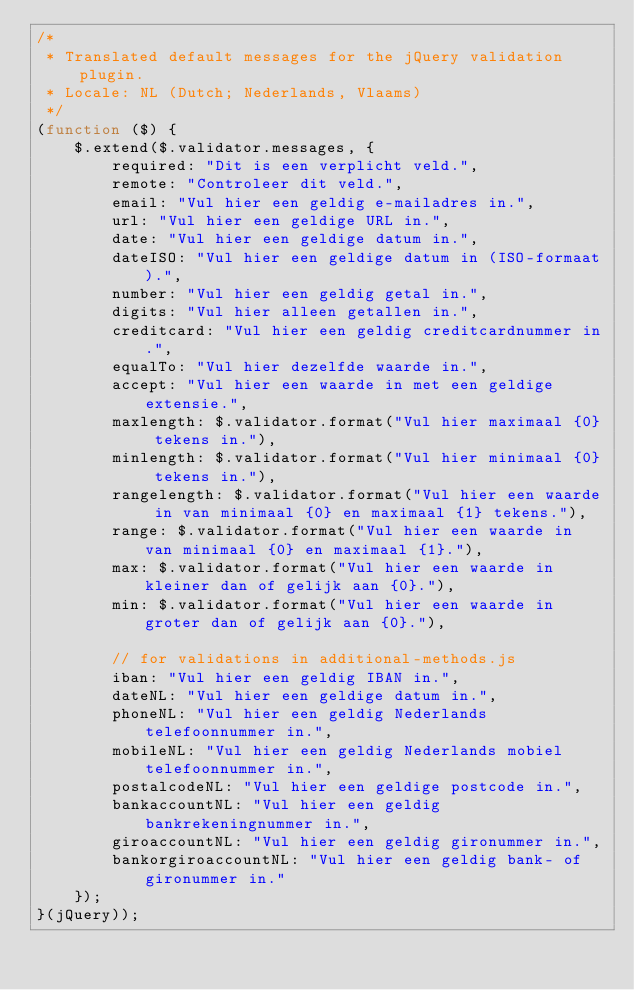<code> <loc_0><loc_0><loc_500><loc_500><_JavaScript_>/*
 * Translated default messages for the jQuery validation plugin.
 * Locale: NL (Dutch; Nederlands, Vlaams)
 */
(function ($) {
    $.extend($.validator.messages, {
        required: "Dit is een verplicht veld.",
        remote: "Controleer dit veld.",
        email: "Vul hier een geldig e-mailadres in.",
        url: "Vul hier een geldige URL in.",
        date: "Vul hier een geldige datum in.",
        dateISO: "Vul hier een geldige datum in (ISO-formaat).",
        number: "Vul hier een geldig getal in.",
        digits: "Vul hier alleen getallen in.",
        creditcard: "Vul hier een geldig creditcardnummer in.",
        equalTo: "Vul hier dezelfde waarde in.",
        accept: "Vul hier een waarde in met een geldige extensie.",
        maxlength: $.validator.format("Vul hier maximaal {0} tekens in."),
        minlength: $.validator.format("Vul hier minimaal {0} tekens in."),
        rangelength: $.validator.format("Vul hier een waarde in van minimaal {0} en maximaal {1} tekens."),
        range: $.validator.format("Vul hier een waarde in van minimaal {0} en maximaal {1}."),
        max: $.validator.format("Vul hier een waarde in kleiner dan of gelijk aan {0}."),
        min: $.validator.format("Vul hier een waarde in groter dan of gelijk aan {0}."),

        // for validations in additional-methods.js
        iban: "Vul hier een geldig IBAN in.",
        dateNL: "Vul hier een geldige datum in.",
        phoneNL: "Vul hier een geldig Nederlands telefoonnummer in.",
        mobileNL: "Vul hier een geldig Nederlands mobiel telefoonnummer in.",
        postalcodeNL: "Vul hier een geldige postcode in.",
        bankaccountNL: "Vul hier een geldig bankrekeningnummer in.",
        giroaccountNL: "Vul hier een geldig gironummer in.",
        bankorgiroaccountNL: "Vul hier een geldig bank- of gironummer in."
    });
}(jQuery));</code> 